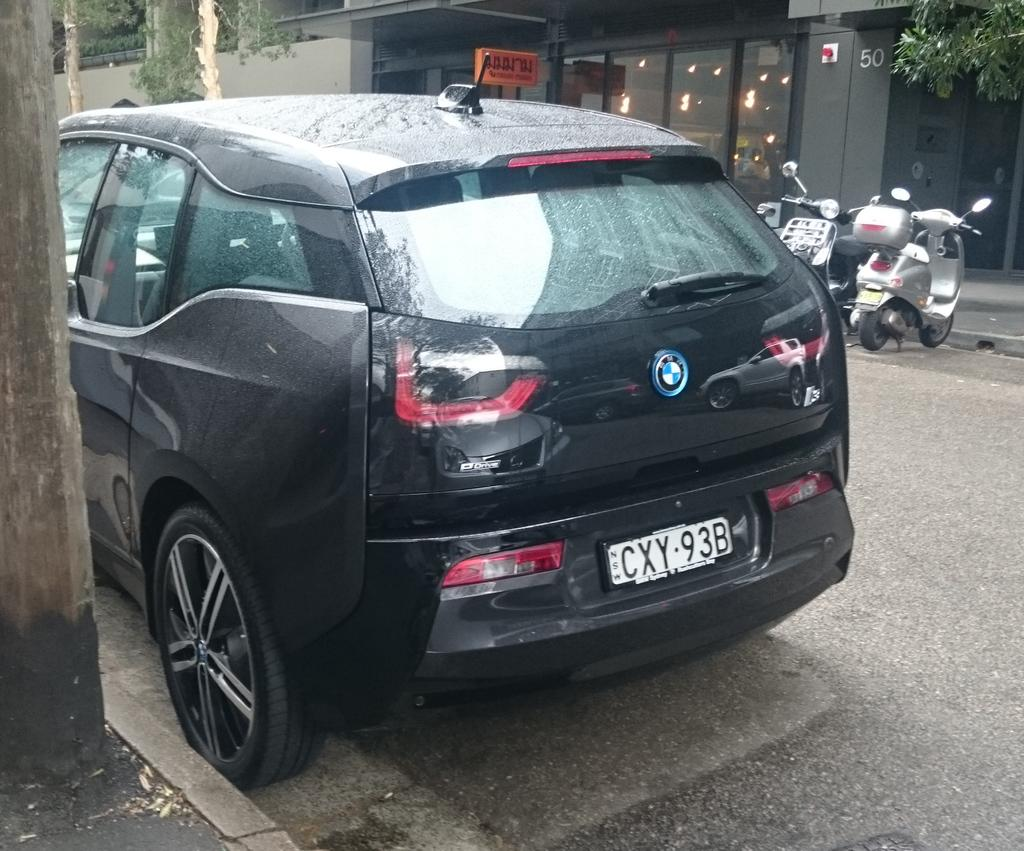What can be seen on the road in the image? There are vehicles on the road in the image. What type of natural elements are visible in the image? There are trees visible in the image. What can be used for illumination in the image? There are lights in the image. What type of structure can be seen in the image? There appears to be a building in the image. Can you see a yam growing near the building in the image? There is no yam growing near the building in the image. Is there a tiger visible in the image? There is no tiger present in the image. 